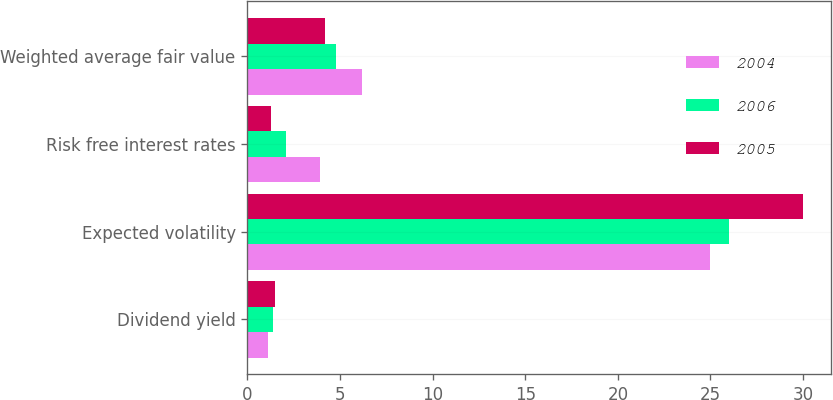Convert chart. <chart><loc_0><loc_0><loc_500><loc_500><stacked_bar_chart><ecel><fcel>Dividend yield<fcel>Expected volatility<fcel>Risk free interest rates<fcel>Weighted average fair value<nl><fcel>2004<fcel>1.1<fcel>25<fcel>3.9<fcel>6.19<nl><fcel>2006<fcel>1.4<fcel>26<fcel>2.1<fcel>4.76<nl><fcel>2005<fcel>1.5<fcel>30<fcel>1.3<fcel>4.18<nl></chart> 